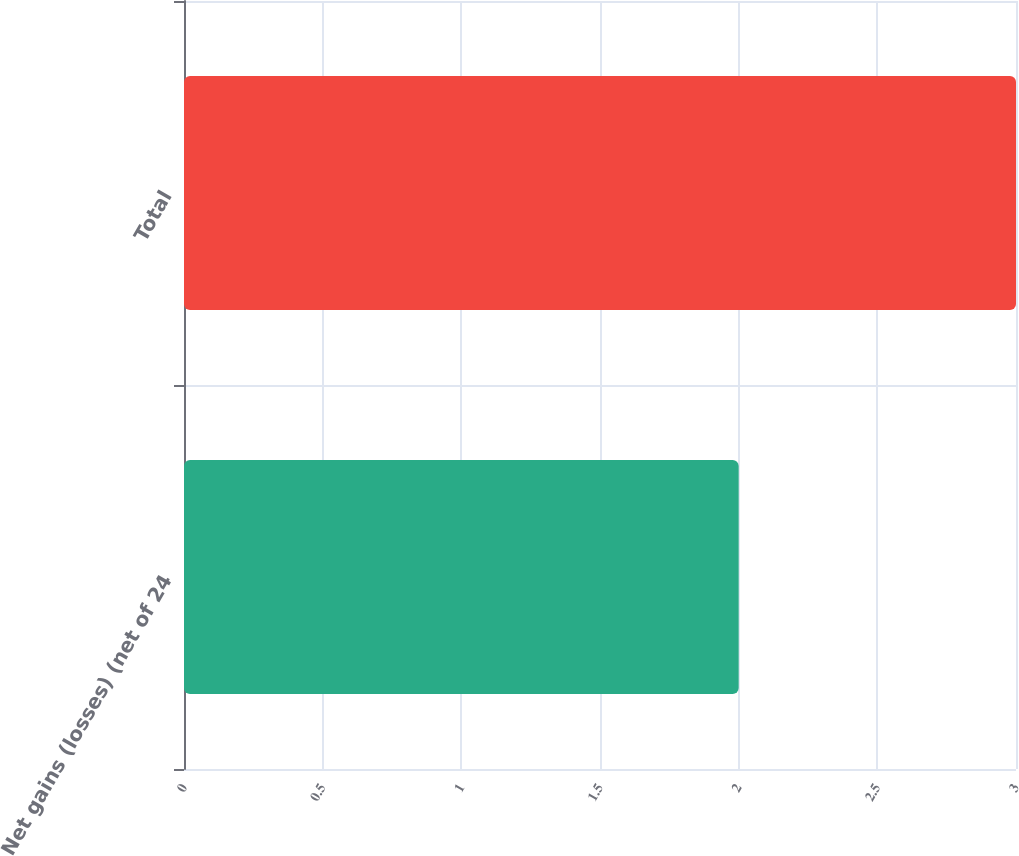<chart> <loc_0><loc_0><loc_500><loc_500><bar_chart><fcel>Net gains (losses) (net of 24<fcel>Total<nl><fcel>2<fcel>3<nl></chart> 